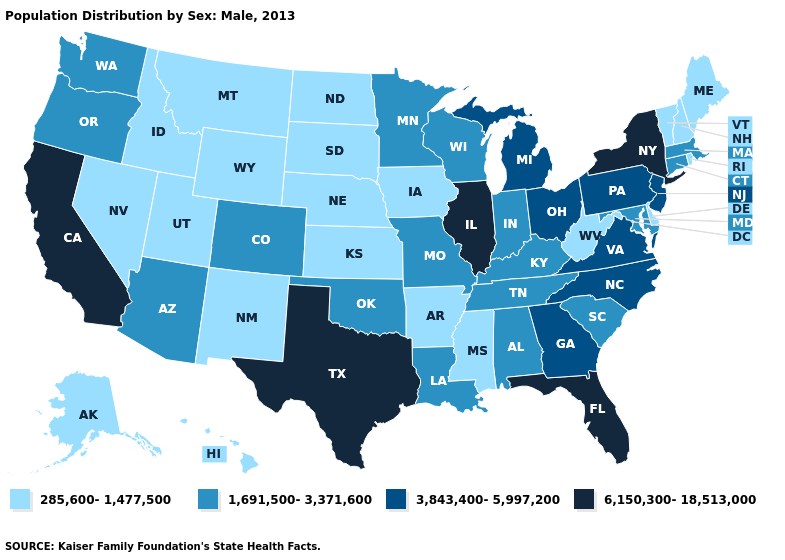Does Washington have the highest value in the West?
Short answer required. No. What is the lowest value in the Northeast?
Concise answer only. 285,600-1,477,500. What is the highest value in states that border Kentucky?
Write a very short answer. 6,150,300-18,513,000. What is the value of Florida?
Be succinct. 6,150,300-18,513,000. Does Indiana have a higher value than Montana?
Keep it brief. Yes. Which states hav the highest value in the West?
Short answer required. California. What is the value of Rhode Island?
Give a very brief answer. 285,600-1,477,500. Does Missouri have a higher value than Michigan?
Quick response, please. No. What is the value of Maryland?
Concise answer only. 1,691,500-3,371,600. Name the states that have a value in the range 6,150,300-18,513,000?
Answer briefly. California, Florida, Illinois, New York, Texas. Among the states that border Tennessee , does Arkansas have the lowest value?
Keep it brief. Yes. Name the states that have a value in the range 285,600-1,477,500?
Give a very brief answer. Alaska, Arkansas, Delaware, Hawaii, Idaho, Iowa, Kansas, Maine, Mississippi, Montana, Nebraska, Nevada, New Hampshire, New Mexico, North Dakota, Rhode Island, South Dakota, Utah, Vermont, West Virginia, Wyoming. Which states have the lowest value in the West?
Short answer required. Alaska, Hawaii, Idaho, Montana, Nevada, New Mexico, Utah, Wyoming. Which states have the lowest value in the Northeast?
Give a very brief answer. Maine, New Hampshire, Rhode Island, Vermont. Name the states that have a value in the range 285,600-1,477,500?
Short answer required. Alaska, Arkansas, Delaware, Hawaii, Idaho, Iowa, Kansas, Maine, Mississippi, Montana, Nebraska, Nevada, New Hampshire, New Mexico, North Dakota, Rhode Island, South Dakota, Utah, Vermont, West Virginia, Wyoming. 